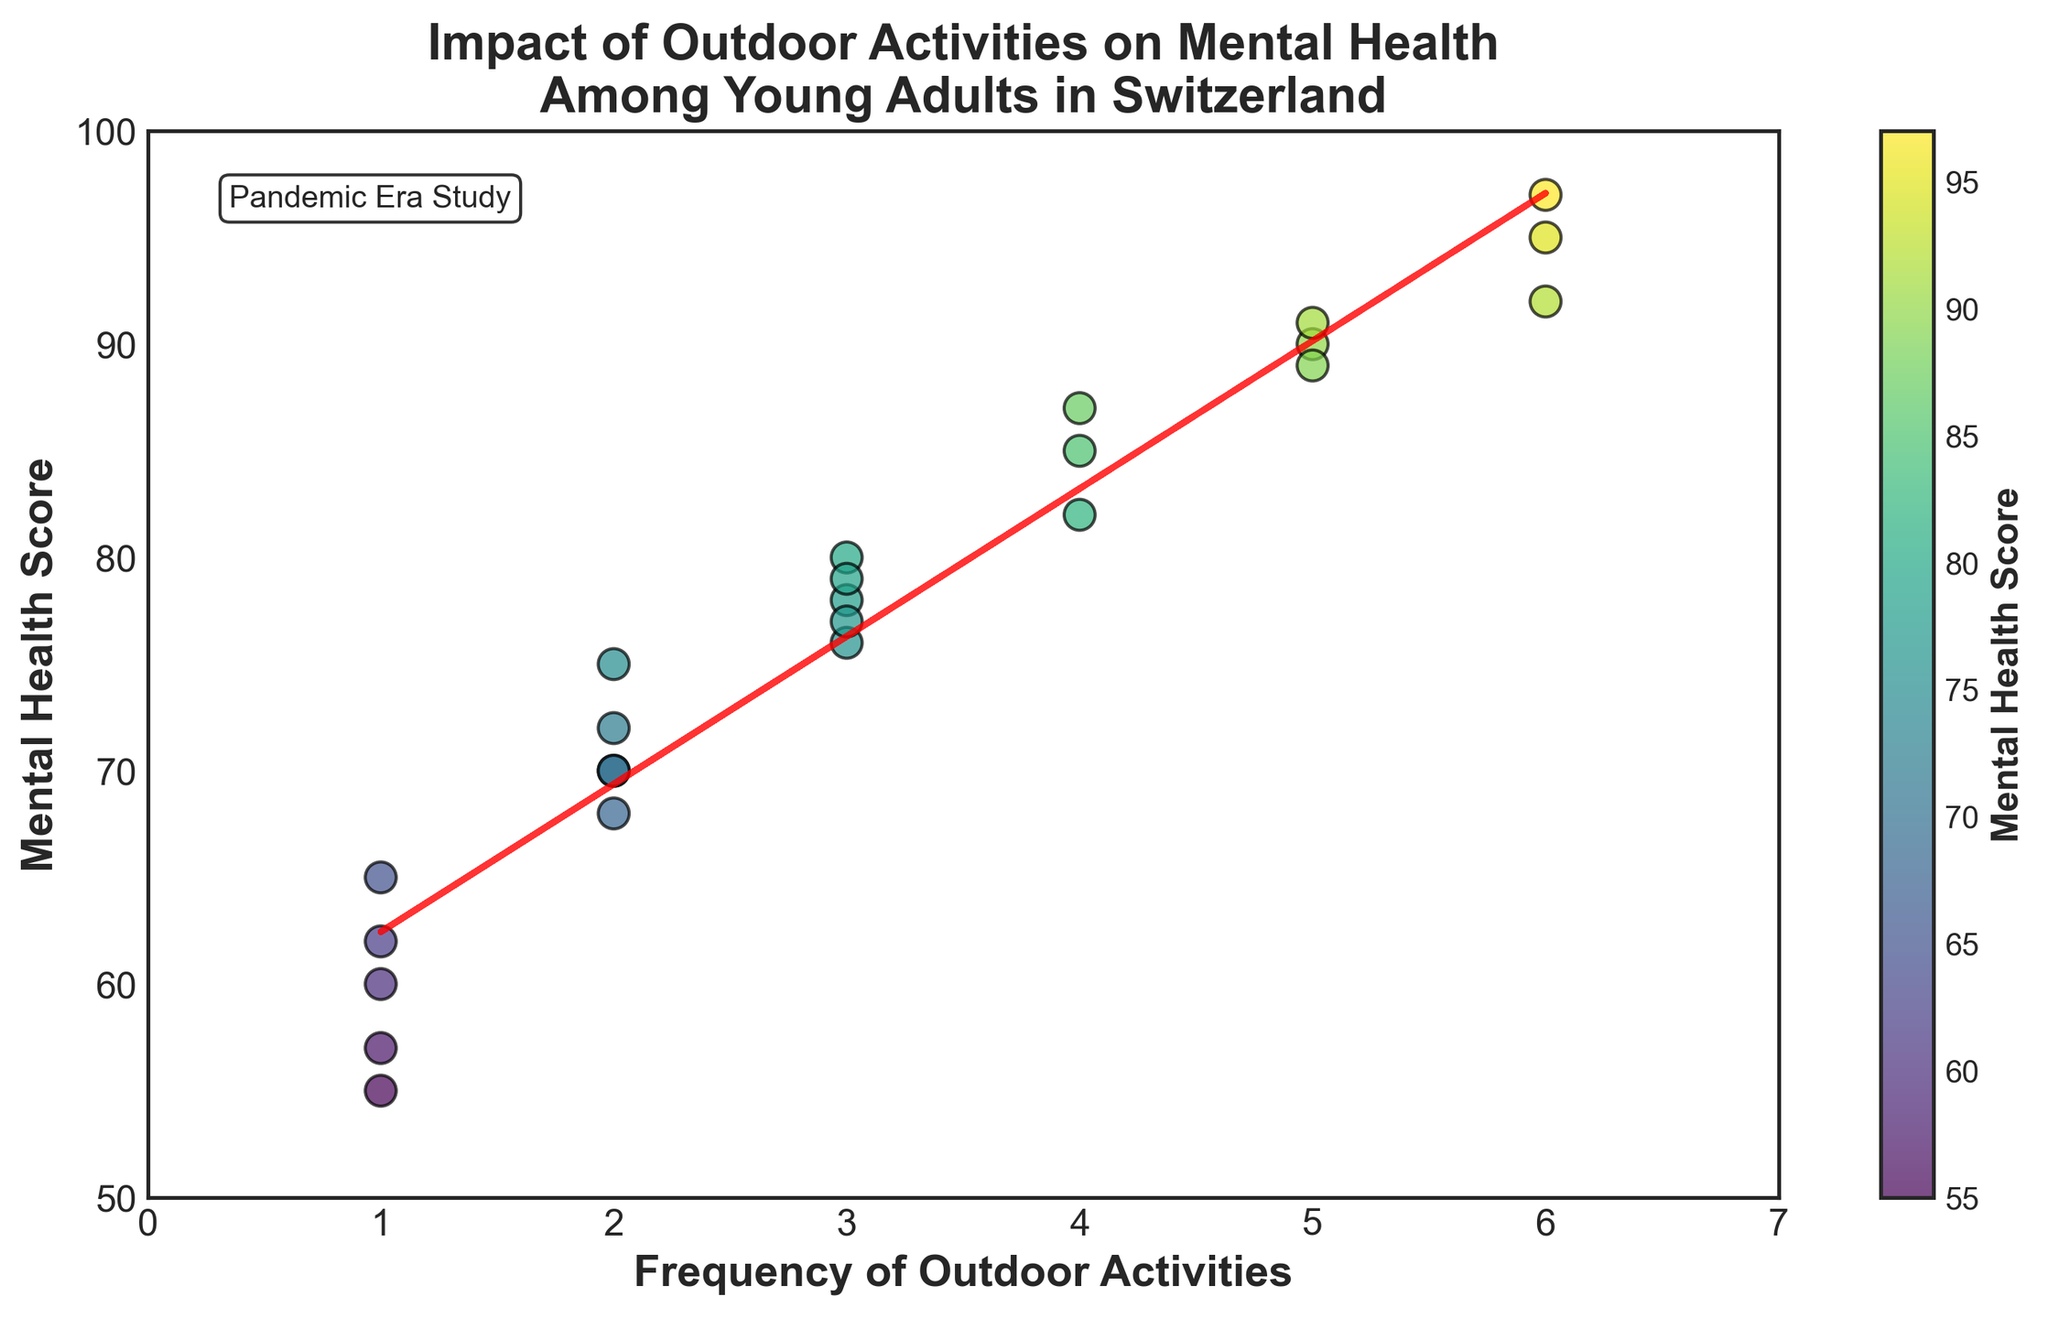What are the axes labels of the scatter plot? The x-axis and y-axis labels are used to identify the variables in the plot. Look at the labels mentioned beside the axes. The x-axis label is 'Frequency of Outdoor Activities' and the y-axis label is 'Mental Health Score'.
Answer: 'Frequency of Outdoor Activities' (x-axis) and 'Mental Health Score' (y-axis) How many data points are displayed in the scatter plot? To find the number of data points, count each individual dot on the scatter plot. By observing the plot, you can see 24 individual dots, corresponding to the 24 data points in the dataset.
Answer: 24 What is the general trend observed between the frequency of outdoor activities and mental health scores? To understand the general trend, look at the direction of the trend line. The trend line is sloping upwards from left to right, indicating a positive relationship. This means that as the frequency of outdoor activities increases, the mental health score also tends to increase.
Answer: Positive relationship What is the highest mental health score observed, and at what frequency of outdoor activities does it occur? Identify the highest point on the y-axis (mental health score) and check the corresponding x-axis value (frequency of outdoor activities). The highest score is 97, which occurs at a frequency of 6 outdoor activities.
Answer: 97 at 6 activities Do lower frequencies of outdoor activities correlate with lower mental health scores? Examine the left end of the x-axis where the frequency is low and observe the corresponding y-axis values. Lower mental health scores (55, 57, 60, 62, 65) are observed at lower frequencies (1, 2). This suggests a correlation where lower frequencies of outdoor activities correspond to lower mental health scores.
Answer: Yes What's the difference in mental health scores between a frequency of 1 and a frequency of 5 outdoor activities? Identify the mental health scores for frequencies of 1 and 5 on the plot, then calculate the difference. The values are (65, 55, 57, 60, 62) for frequency 1 and (90, 89, 91) for frequency 5. The average values are [(65+55+57+60+62)/5 = 59.8] for 1 and [(90+89+91)/3 = 90] for 5. The difference is 90 - 59.8 = 30.2.
Answer: 30.2 Which color represents higher mental health scores in the scatter plot? Look at the color gradient in the scatter plot and the color bar. Higher mental health scores are represented by the lightest colors on the color bar, which are lighter shades of yellow.
Answer: Lightest colors How does the mental health score at a frequency of 4 compare to the score at a frequency of 2? Identify the mental health scores for frequencies of 4 and 2. For frequency 4, the values are (85, 82, 87). For frequency 2, the values are (70, 75, 68, 72, 70). Find the averages: [ (85+82+87)/3 = 84.67 for 4, and (70+75+68+72+70)/5 = 71 for 2 ]. Compare the averages, 84.67 > 71.
Answer: Score at 4 is higher What is the range of mental health scores observed in the scatter plot? To find the range, identify the minimum and maximum mental health scores. The minimum score observed is 55 and the maximum score is 97. Calculate the range by subtracting the minimum from the maximum: 97 - 55 = 42.
Answer: 42 Does the trend line indicate a significant variation or a consistent relationship between the frequency of outdoor activities and mental health score? Look at the trend line and see how closely the data points are clustered around it. The data points largely follow the trend line with some variability, indicating a consistent relationship but with some variation.
Answer: Consistent relationship 